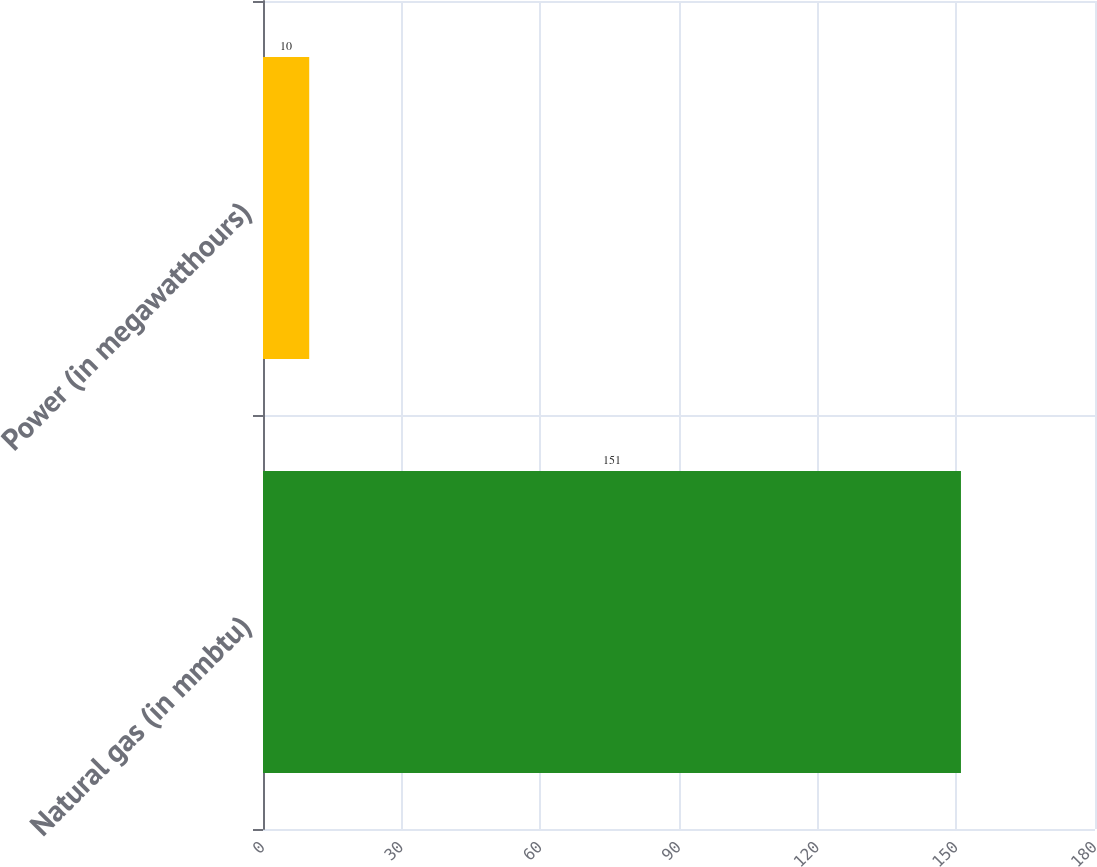Convert chart. <chart><loc_0><loc_0><loc_500><loc_500><bar_chart><fcel>Natural gas (in mmbtu)<fcel>Power (in megawatthours)<nl><fcel>151<fcel>10<nl></chart> 